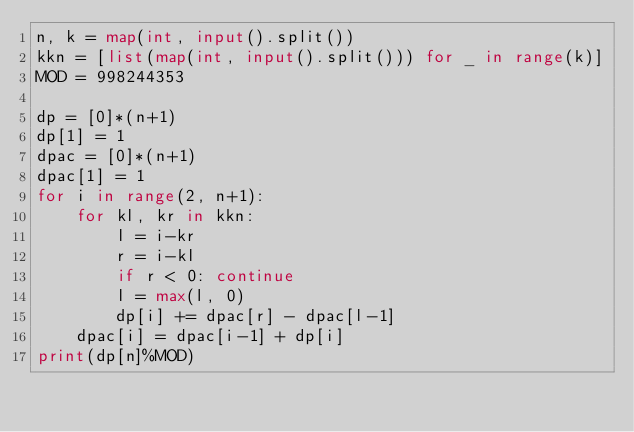<code> <loc_0><loc_0><loc_500><loc_500><_Python_>n, k = map(int, input().split())
kkn = [list(map(int, input().split())) for _ in range(k)]
MOD = 998244353

dp = [0]*(n+1)
dp[1] = 1
dpac = [0]*(n+1)
dpac[1] = 1
for i in range(2, n+1):
    for kl, kr in kkn:
        l = i-kr
        r = i-kl
        if r < 0: continue
        l = max(l, 0)
        dp[i] += dpac[r] - dpac[l-1]
    dpac[i] = dpac[i-1] + dp[i]
print(dp[n]%MOD)</code> 